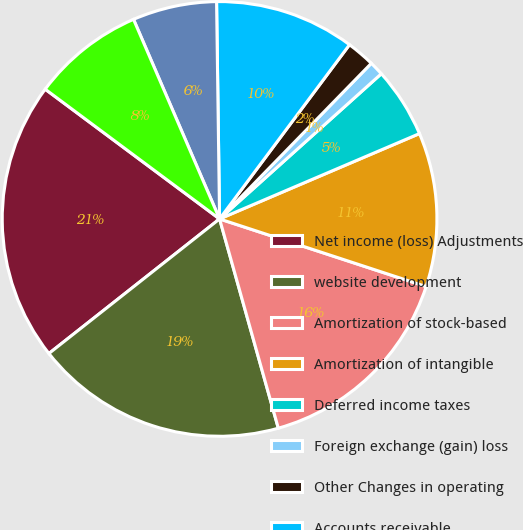<chart> <loc_0><loc_0><loc_500><loc_500><pie_chart><fcel>Net income (loss) Adjustments<fcel>website development<fcel>Amortization of stock-based<fcel>Amortization of intangible<fcel>Deferred income taxes<fcel>Foreign exchange (gain) loss<fcel>Other Changes in operating<fcel>Accounts receivable<fcel>Prepaid expenses prepaid<fcel>Accounts payable merchant<nl><fcel>20.81%<fcel>18.73%<fcel>15.61%<fcel>11.46%<fcel>5.22%<fcel>1.06%<fcel>2.1%<fcel>10.42%<fcel>6.26%<fcel>8.34%<nl></chart> 